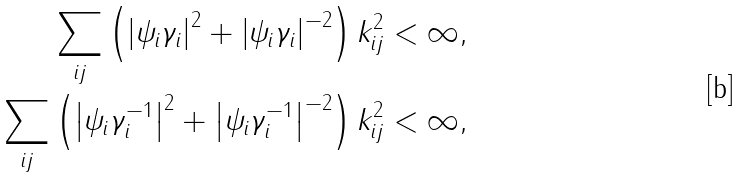<formula> <loc_0><loc_0><loc_500><loc_500>\sum _ { i j } \left ( \left | \psi _ { i } \gamma _ { i } \right | ^ { 2 } + \left | \psi _ { i } \gamma _ { i } \right | ^ { - 2 } \right ) k _ { i j } ^ { 2 } < \infty , \\ \sum _ { i j } \left ( \left | \psi _ { i } \gamma _ { i } ^ { - 1 } \right | ^ { 2 } + \left | \psi _ { i } \gamma _ { i } ^ { - 1 } \right | ^ { - 2 } \right ) k _ { i j } ^ { 2 } < \infty ,</formula> 